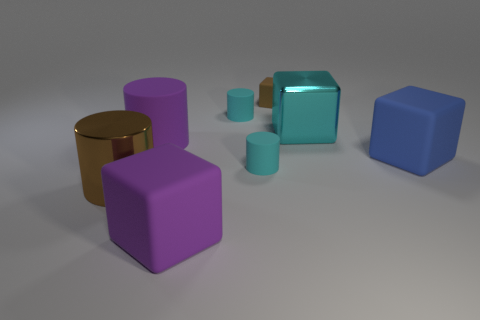Subtract 1 blocks. How many blocks are left? 3 Add 2 brown matte blocks. How many objects exist? 10 Add 1 large gray rubber spheres. How many large gray rubber spheres exist? 1 Subtract 1 cyan cubes. How many objects are left? 7 Subtract all large purple matte cubes. Subtract all small gray matte things. How many objects are left? 7 Add 1 metallic objects. How many metallic objects are left? 3 